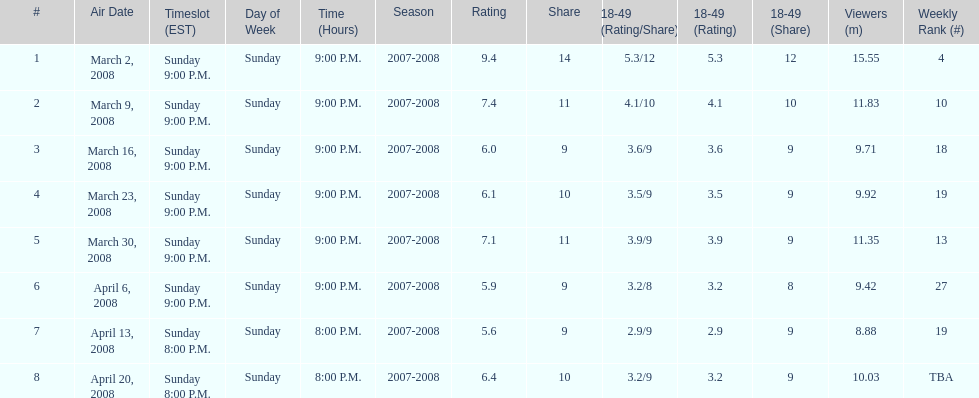The air date with the most viewers March 2, 2008. 